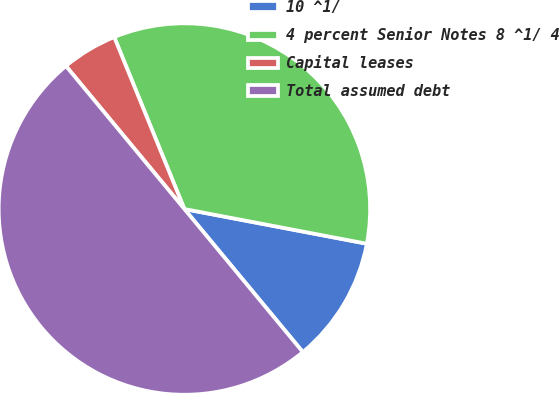<chart> <loc_0><loc_0><loc_500><loc_500><pie_chart><fcel>10 ^1/<fcel>4 percent Senior Notes 8 ^1/ 4<fcel>Capital leases<fcel>Total assumed debt<nl><fcel>11.0%<fcel>34.16%<fcel>4.84%<fcel>50.0%<nl></chart> 